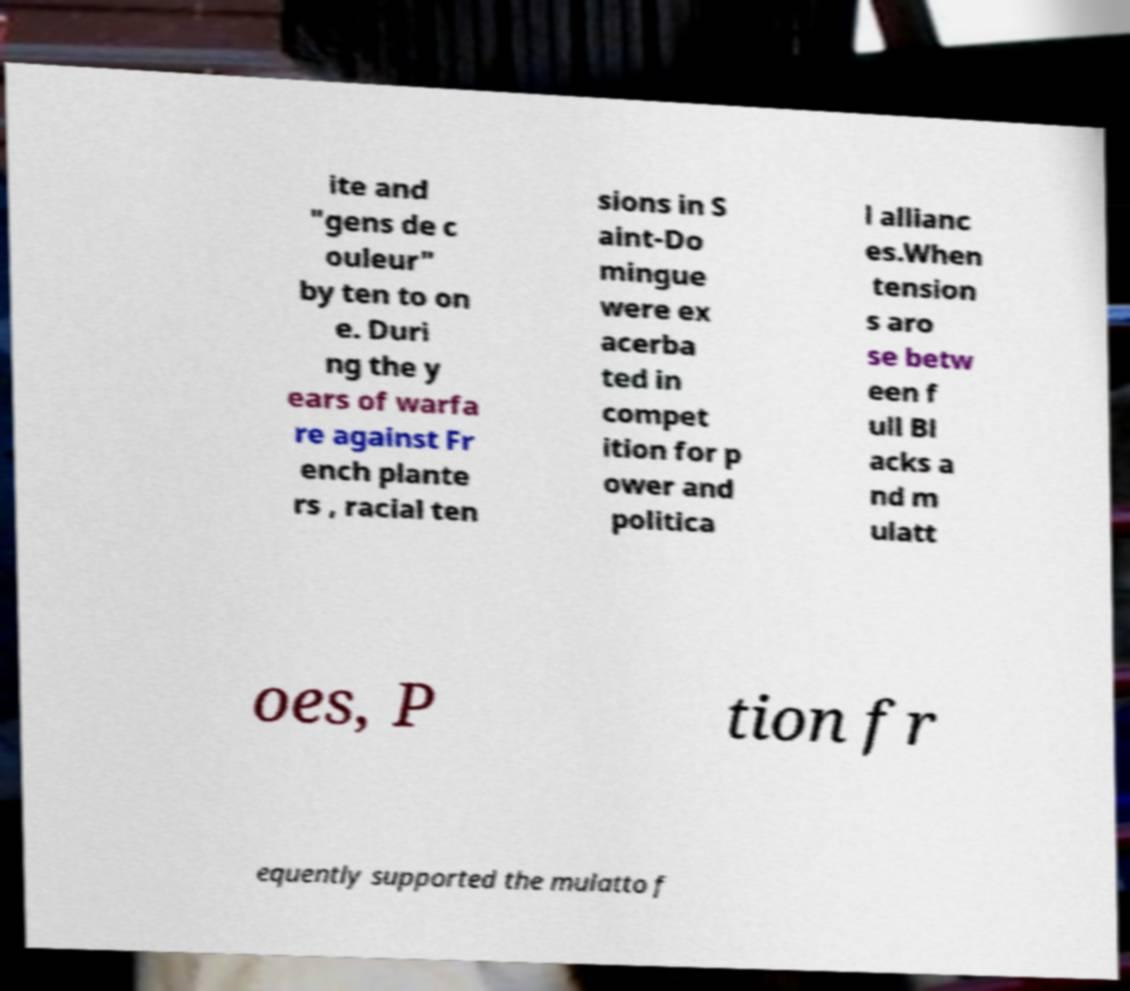Please identify and transcribe the text found in this image. ite and "gens de c ouleur" by ten to on e. Duri ng the y ears of warfa re against Fr ench plante rs , racial ten sions in S aint-Do mingue were ex acerba ted in compet ition for p ower and politica l allianc es.When tension s aro se betw een f ull Bl acks a nd m ulatt oes, P tion fr equently supported the mulatto f 